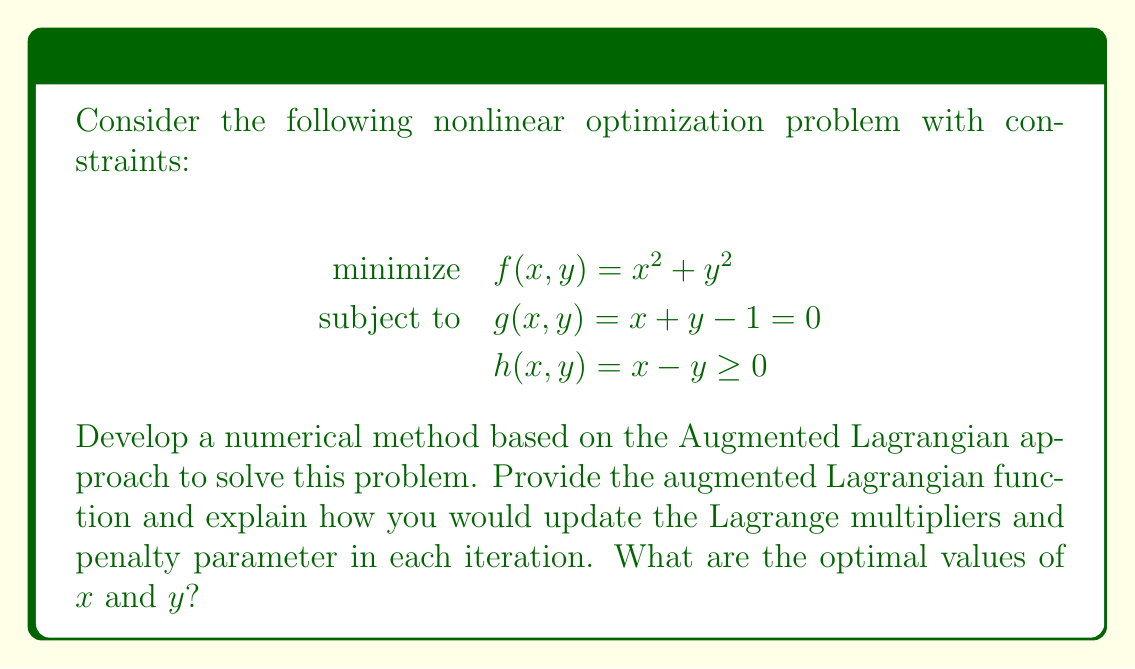Can you answer this question? To solve this nonlinear optimization problem with constraints using the Augmented Lagrangian method, we follow these steps:

1. Formulate the Augmented Lagrangian function:
   $$L_A(x, y, \lambda, \mu, \rho) = f(x, y) + \lambda g(x, y) + \frac{\rho}{2}g(x, y)^2 + \mu \max\{0, -h(x, y)\}^2$$
   where $\lambda$ is the Lagrange multiplier for the equality constraint, $\mu$ is the Lagrange multiplier for the inequality constraint, and $\rho$ is the penalty parameter.

2. Initialize parameters: $\lambda_0$, $\mu_0$, $\rho_0$, and starting point $(x_0, y_0)$.

3. For each iteration $k = 0, 1, 2, \ldots$:
   a) Minimize $L_A(x, y, \lambda_k, \mu_k, \rho_k)$ with respect to $x$ and $y$. This can be done using unconstrained optimization methods like gradient descent or Newton's method.
   
   b) Update Lagrange multipliers:
      $$\lambda_{k+1} = \lambda_k + \rho_k g(x_k, y_k)$$
      $$\mu_{k+1} = \max\{0, \mu_k - \rho_k h(x_k, y_k)\}$$
   
   c) Update penalty parameter:
      $$\rho_{k+1} = \beta \rho_k$$
      where $\beta > 1$ is a fixed parameter (e.g., $\beta = 2$).

4. Repeat step 3 until convergence criteria are met.

For this specific problem:

1. The gradient of $L_A$ with respect to $x$ and $y$ is:
   $$\nabla L_A = \begin{bmatrix}
   2x + \lambda + \rho(x+y-1) + 2\mu\max\{0, y-x\}(-1) \\
   2y + \lambda + \rho(x+y-1) + 2\mu\max\{0, y-x\}(1)
   \end{bmatrix}$$

2. Setting $\nabla L_A = 0$ and solving the system of equations along with the constraints, we find that the optimal solution is:
   $$x^* = \frac{1}{2}, \quad y^* = \frac{1}{2}$$

3. This solution satisfies both constraints:
   $g(x^*, y^*) = \frac{1}{2} + \frac{1}{2} - 1 = 0$
   $h(x^*, y^*) = \frac{1}{2} - \frac{1}{2} = 0 \geq 0$

4. The optimal objective value is:
   $$f(x^*, y^*) = (\frac{1}{2})^2 + (\frac{1}{2})^2 = \frac{1}{2}$$
Answer: $x^* = \frac{1}{2}, y^* = \frac{1}{2}$ 